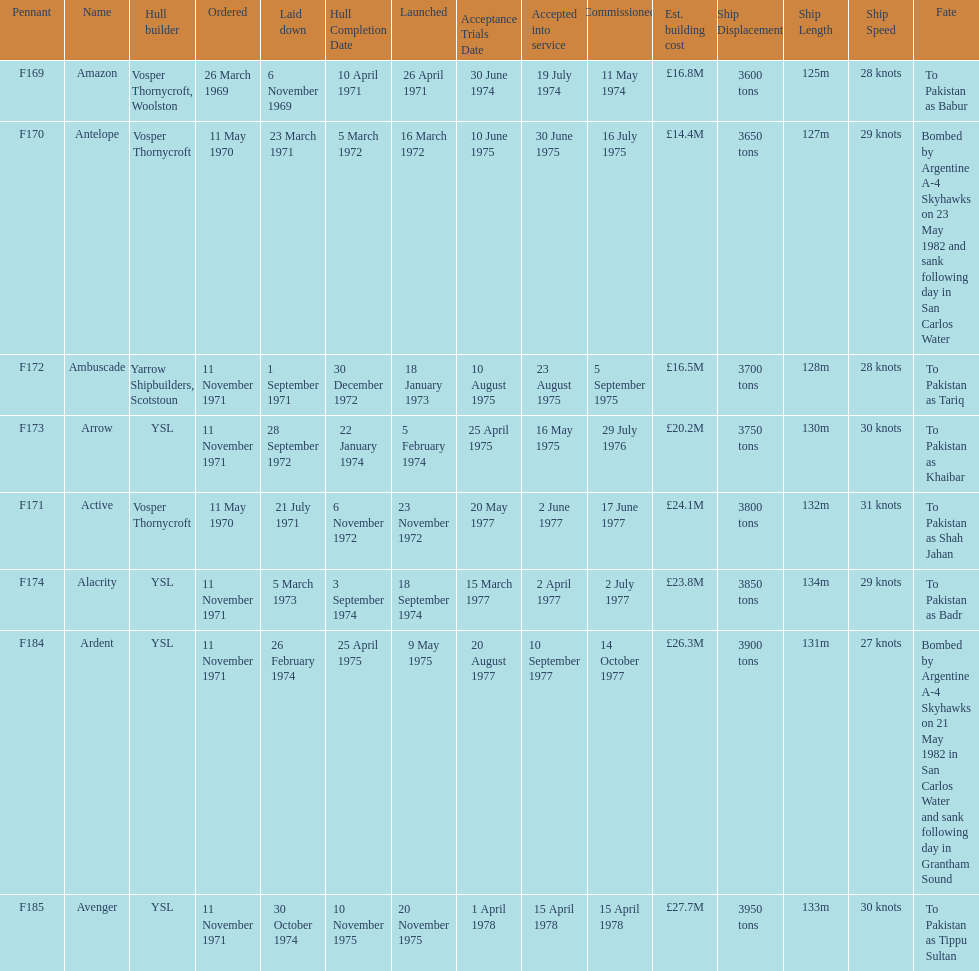Which ship had the highest estimated cost to build? Avenger. 